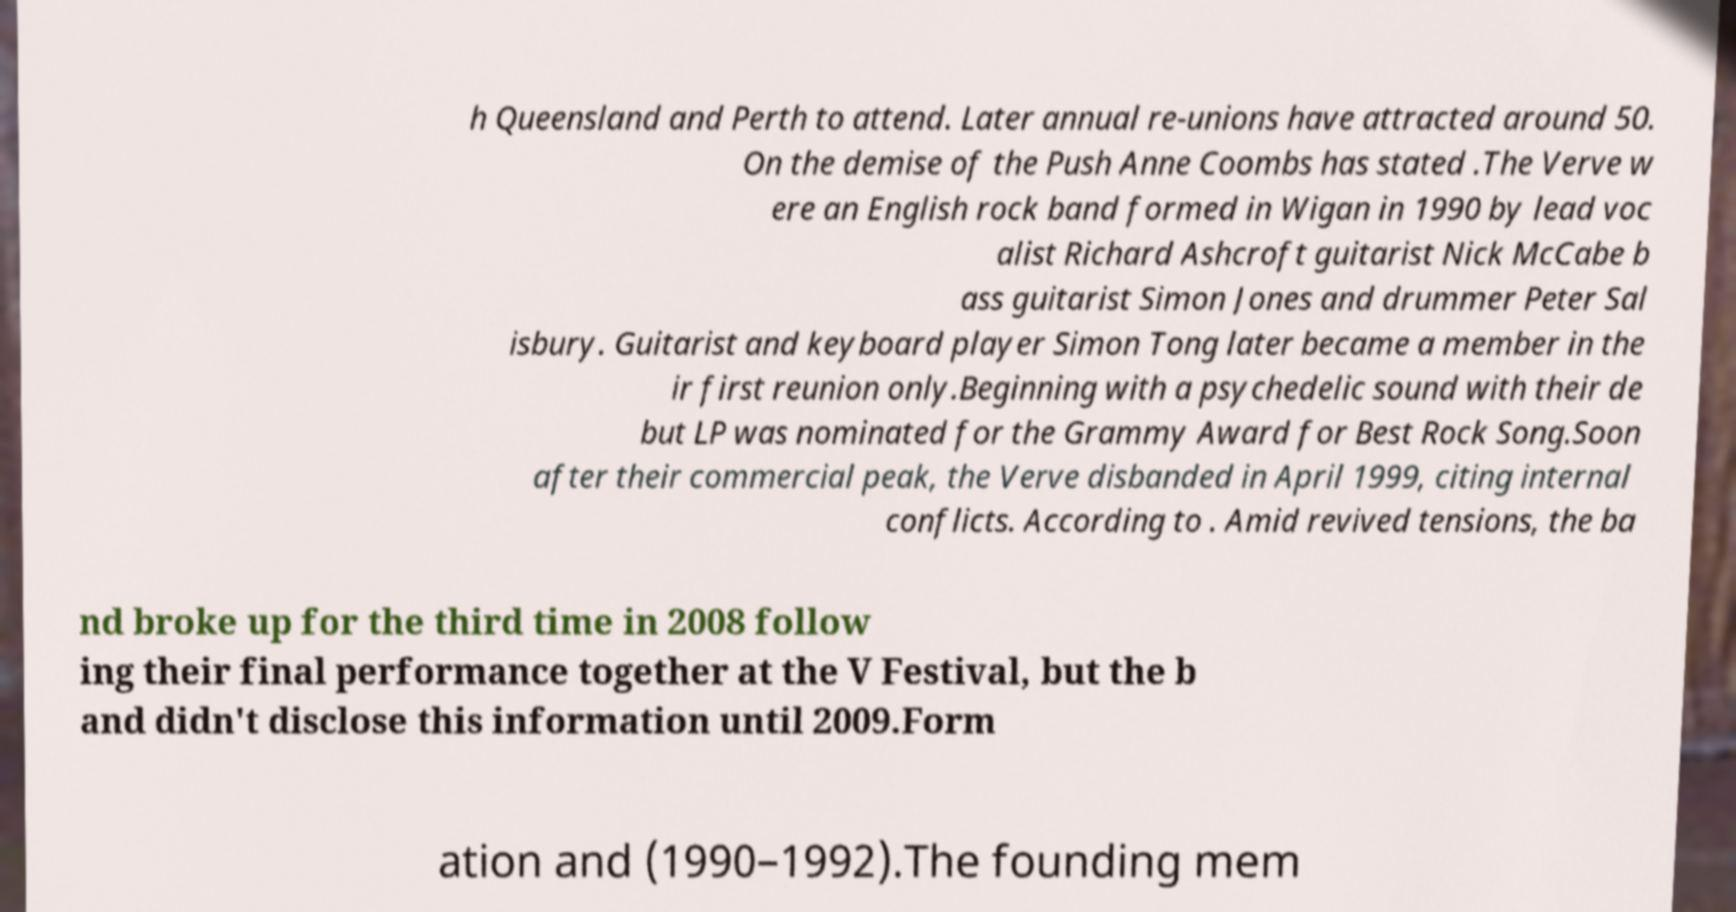Please identify and transcribe the text found in this image. h Queensland and Perth to attend. Later annual re-unions have attracted around 50. On the demise of the Push Anne Coombs has stated .The Verve w ere an English rock band formed in Wigan in 1990 by lead voc alist Richard Ashcroft guitarist Nick McCabe b ass guitarist Simon Jones and drummer Peter Sal isbury. Guitarist and keyboard player Simon Tong later became a member in the ir first reunion only.Beginning with a psychedelic sound with their de but LP was nominated for the Grammy Award for Best Rock Song.Soon after their commercial peak, the Verve disbanded in April 1999, citing internal conflicts. According to . Amid revived tensions, the ba nd broke up for the third time in 2008 follow ing their final performance together at the V Festival, but the b and didn't disclose this information until 2009.Form ation and (1990–1992).The founding mem 